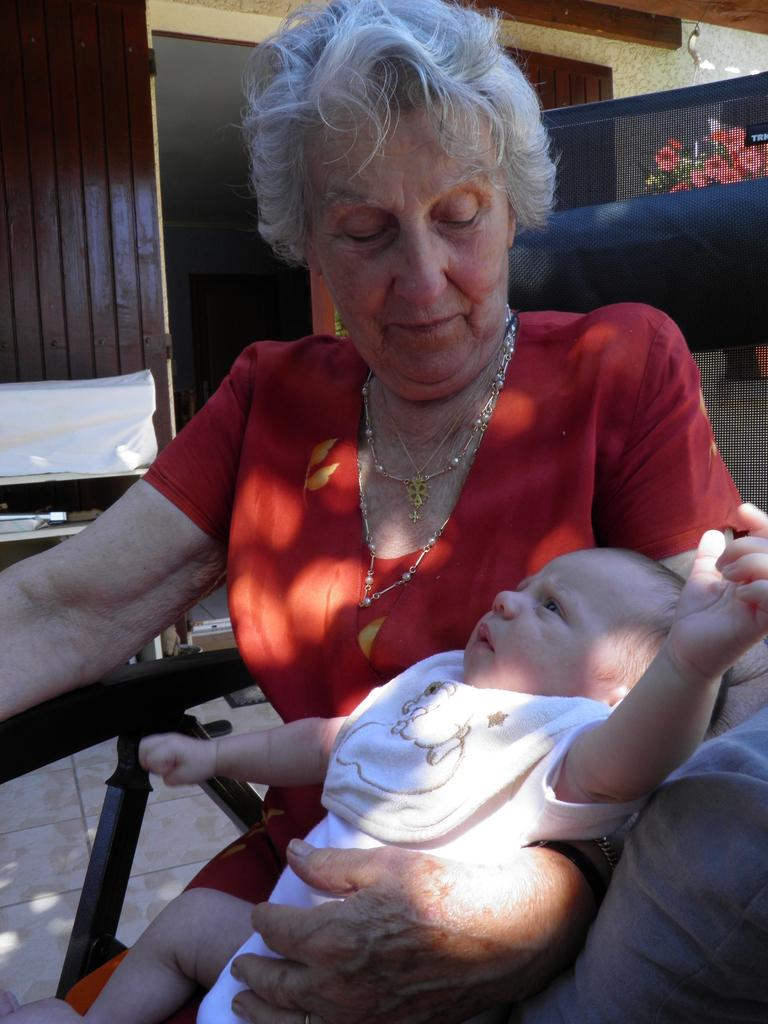What is the woman in the image doing? The woman is seated and holding a baby in the image. What can be seen in the image besides the woman and the baby? There is a plant with flowers in the image. What might be visible in the background of the image? There appears to be a door in the background of the image. What grade does the man in the image teach? There is no man present in the image, so it is not possible to determine what grade he might teach. 